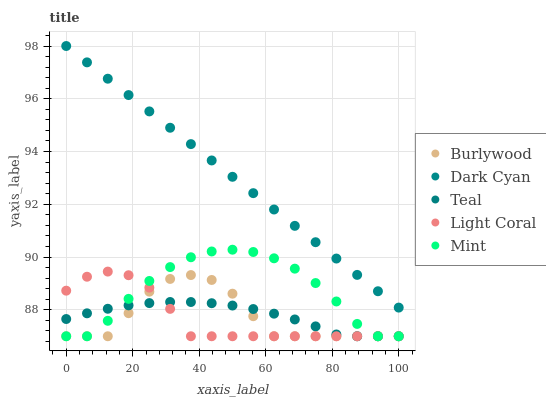Does Light Coral have the minimum area under the curve?
Answer yes or no. Yes. Does Dark Cyan have the maximum area under the curve?
Answer yes or no. Yes. Does Dark Cyan have the minimum area under the curve?
Answer yes or no. No. Does Light Coral have the maximum area under the curve?
Answer yes or no. No. Is Dark Cyan the smoothest?
Answer yes or no. Yes. Is Burlywood the roughest?
Answer yes or no. Yes. Is Light Coral the smoothest?
Answer yes or no. No. Is Light Coral the roughest?
Answer yes or no. No. Does Burlywood have the lowest value?
Answer yes or no. Yes. Does Dark Cyan have the lowest value?
Answer yes or no. No. Does Dark Cyan have the highest value?
Answer yes or no. Yes. Does Light Coral have the highest value?
Answer yes or no. No. Is Burlywood less than Dark Cyan?
Answer yes or no. Yes. Is Dark Cyan greater than Teal?
Answer yes or no. Yes. Does Teal intersect Burlywood?
Answer yes or no. Yes. Is Teal less than Burlywood?
Answer yes or no. No. Is Teal greater than Burlywood?
Answer yes or no. No. Does Burlywood intersect Dark Cyan?
Answer yes or no. No. 